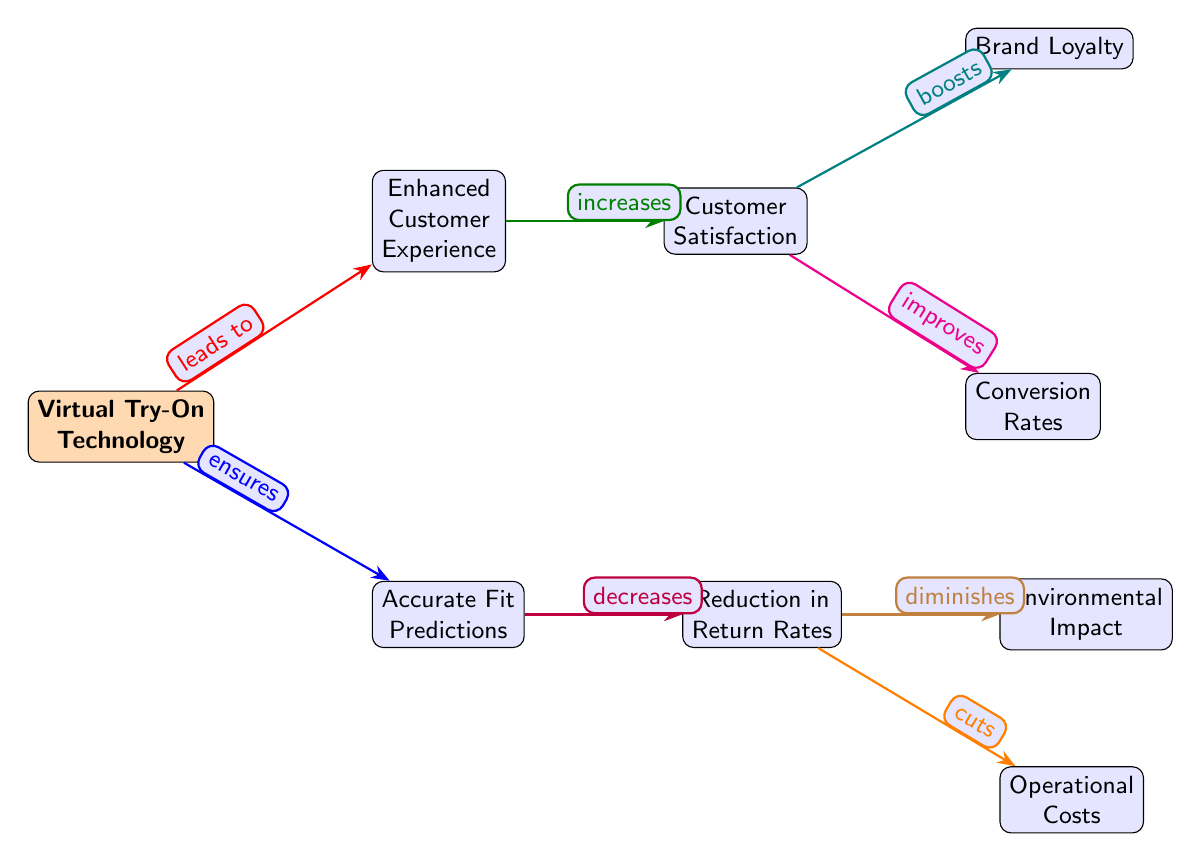What is the main node of the diagram? The main node is labeled as "Virtual Try-On Technology." It serves as the central concept from which other nodes branch out.
Answer: Virtual Try-On Technology How many nodes are in the diagram? By counting each labeled section in the diagram, there are a total of nine nodes present.
Answer: 9 What is the relationship between "Virtual Try-On Technology" and "Enhanced Customer Experience"? The edge connecting these two nodes is labeled "leads to." This indicates that the main node influences or results in the enhanced experience for customers.
Answer: leads to Which node is a result of "Accurate Fit Predictions"? The edge from "Accurate Fit Predictions" leads to "Reduction in Return Rates." This indicates that accurate fit predictions contribute to a decrease in the return rates for products.
Answer: Reduction in Return Rates What is the effect of "Customer Satisfaction" on "Brand Loyalty"? The edge indicates "boosts," showing that higher customer satisfaction is connected to an increase in brand loyalty. Therefore, customer satisfaction positively affects brand loyalty.
Answer: boosts How does "Reduction in Return Rates" impact "Operational Costs"? The edge indicates "cuts," meaning that a decrease in return rates will directly reduce operational costs related to handling returns.
Answer: cuts What leads to "Conversion Rates"? The edge from "Customer Satisfaction" points to "Conversion Rates," labeled as "improves," showing that better customer satisfaction helps improve the rates at which potential buyers make purchases.
Answer: improves What does "Virtual Try-On Technology" ensure? The edge connects "Virtual Try-On Technology" to "Accurate Fit Predictions" and is labeled "ensures." This indicates that this technology establishes the accuracy in fit predictions for customers.
Answer: Accurate Fit Predictions 